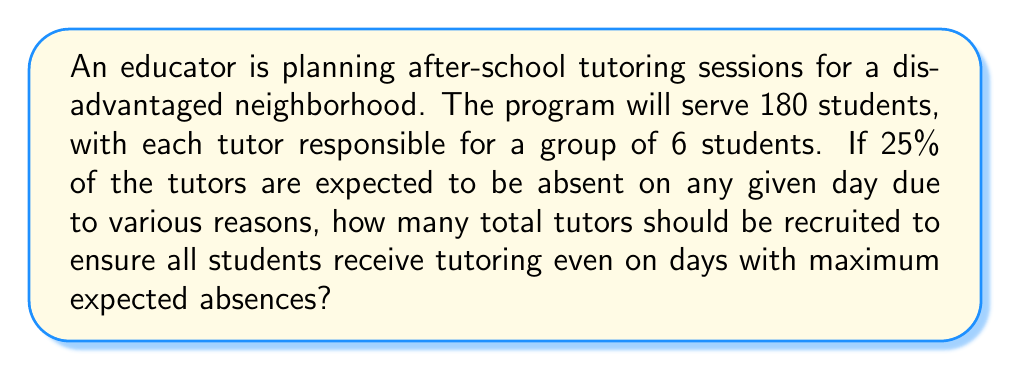What is the answer to this math problem? Let's approach this problem step by step:

1. Calculate the number of tutors needed if there were no absences:
   $$\text{Tutors needed} = \frac{\text{Total students}}{\text{Students per tutor}} = \frac{180}{6} = 30$$

2. Calculate the percentage of tutors that need to be present:
   $$\text{Percentage present} = 100\% - \text{Percentage absent} = 100\% - 25\% = 75\%$$

3. Let $x$ be the total number of tutors to be recruited. We need 75% of $x$ to equal 30:
   $$0.75x = 30$$

4. Solve for $x$:
   $$x = \frac{30}{0.75} = 40$$

5. Check: If we recruit 40 tutors and 25% are absent, we'll have:
   $$40 - (40 \times 0.25) = 40 - 10 = 30$$ tutors available, which is exactly what we need.

Therefore, the program should recruit 40 tutors to ensure all students receive tutoring even on days with maximum expected absences.
Answer: 40 tutors 